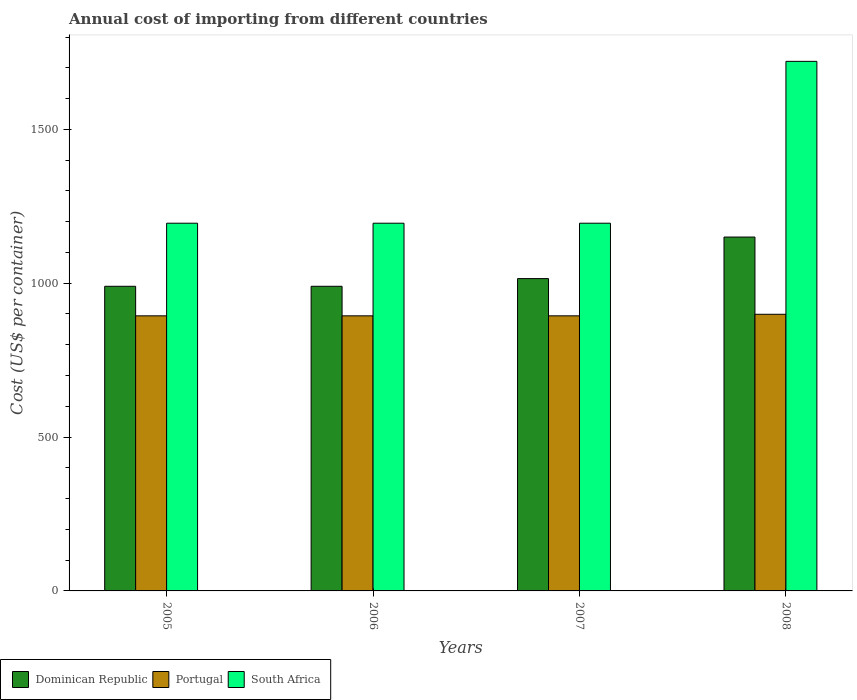How many different coloured bars are there?
Your answer should be very brief. 3. Are the number of bars per tick equal to the number of legend labels?
Offer a very short reply. Yes. What is the label of the 4th group of bars from the left?
Give a very brief answer. 2008. What is the total annual cost of importing in Portugal in 2008?
Give a very brief answer. 899. Across all years, what is the maximum total annual cost of importing in Portugal?
Offer a terse response. 899. Across all years, what is the minimum total annual cost of importing in South Africa?
Offer a very short reply. 1195. In which year was the total annual cost of importing in Portugal maximum?
Offer a terse response. 2008. In which year was the total annual cost of importing in Dominican Republic minimum?
Your answer should be compact. 2005. What is the total total annual cost of importing in Portugal in the graph?
Your answer should be compact. 3581. What is the difference between the total annual cost of importing in South Africa in 2007 and that in 2008?
Offer a very short reply. -526. What is the difference between the total annual cost of importing in Portugal in 2008 and the total annual cost of importing in South Africa in 2007?
Offer a very short reply. -296. What is the average total annual cost of importing in Portugal per year?
Offer a terse response. 895.25. In the year 2005, what is the difference between the total annual cost of importing in Portugal and total annual cost of importing in South Africa?
Give a very brief answer. -301. Is the total annual cost of importing in Portugal in 2007 less than that in 2008?
Your response must be concise. Yes. What is the difference between the highest and the second highest total annual cost of importing in Portugal?
Ensure brevity in your answer.  5. What is the difference between the highest and the lowest total annual cost of importing in Dominican Republic?
Your answer should be very brief. 160. In how many years, is the total annual cost of importing in Portugal greater than the average total annual cost of importing in Portugal taken over all years?
Provide a short and direct response. 1. What does the 1st bar from the left in 2008 represents?
Offer a very short reply. Dominican Republic. What does the 1st bar from the right in 2007 represents?
Offer a terse response. South Africa. Are all the bars in the graph horizontal?
Your response must be concise. No. How many years are there in the graph?
Offer a terse response. 4. What is the difference between two consecutive major ticks on the Y-axis?
Offer a terse response. 500. Are the values on the major ticks of Y-axis written in scientific E-notation?
Your answer should be very brief. No. Where does the legend appear in the graph?
Make the answer very short. Bottom left. How many legend labels are there?
Offer a very short reply. 3. What is the title of the graph?
Provide a short and direct response. Annual cost of importing from different countries. What is the label or title of the X-axis?
Your answer should be very brief. Years. What is the label or title of the Y-axis?
Offer a terse response. Cost (US$ per container). What is the Cost (US$ per container) in Dominican Republic in 2005?
Provide a succinct answer. 990. What is the Cost (US$ per container) in Portugal in 2005?
Make the answer very short. 894. What is the Cost (US$ per container) in South Africa in 2005?
Offer a terse response. 1195. What is the Cost (US$ per container) in Dominican Republic in 2006?
Give a very brief answer. 990. What is the Cost (US$ per container) in Portugal in 2006?
Offer a terse response. 894. What is the Cost (US$ per container) of South Africa in 2006?
Your answer should be compact. 1195. What is the Cost (US$ per container) in Dominican Republic in 2007?
Give a very brief answer. 1015. What is the Cost (US$ per container) in Portugal in 2007?
Ensure brevity in your answer.  894. What is the Cost (US$ per container) of South Africa in 2007?
Your answer should be compact. 1195. What is the Cost (US$ per container) in Dominican Republic in 2008?
Keep it short and to the point. 1150. What is the Cost (US$ per container) of Portugal in 2008?
Make the answer very short. 899. What is the Cost (US$ per container) of South Africa in 2008?
Provide a short and direct response. 1721. Across all years, what is the maximum Cost (US$ per container) of Dominican Republic?
Your answer should be compact. 1150. Across all years, what is the maximum Cost (US$ per container) in Portugal?
Your response must be concise. 899. Across all years, what is the maximum Cost (US$ per container) of South Africa?
Provide a short and direct response. 1721. Across all years, what is the minimum Cost (US$ per container) of Dominican Republic?
Your answer should be very brief. 990. Across all years, what is the minimum Cost (US$ per container) in Portugal?
Your answer should be very brief. 894. Across all years, what is the minimum Cost (US$ per container) of South Africa?
Your response must be concise. 1195. What is the total Cost (US$ per container) in Dominican Republic in the graph?
Keep it short and to the point. 4145. What is the total Cost (US$ per container) of Portugal in the graph?
Provide a short and direct response. 3581. What is the total Cost (US$ per container) in South Africa in the graph?
Ensure brevity in your answer.  5306. What is the difference between the Cost (US$ per container) of Dominican Republic in 2005 and that in 2006?
Offer a very short reply. 0. What is the difference between the Cost (US$ per container) in South Africa in 2005 and that in 2006?
Your response must be concise. 0. What is the difference between the Cost (US$ per container) of Dominican Republic in 2005 and that in 2008?
Offer a terse response. -160. What is the difference between the Cost (US$ per container) in Portugal in 2005 and that in 2008?
Keep it short and to the point. -5. What is the difference between the Cost (US$ per container) of South Africa in 2005 and that in 2008?
Offer a very short reply. -526. What is the difference between the Cost (US$ per container) in Dominican Republic in 2006 and that in 2008?
Offer a terse response. -160. What is the difference between the Cost (US$ per container) of Portugal in 2006 and that in 2008?
Offer a terse response. -5. What is the difference between the Cost (US$ per container) in South Africa in 2006 and that in 2008?
Make the answer very short. -526. What is the difference between the Cost (US$ per container) of Dominican Republic in 2007 and that in 2008?
Your response must be concise. -135. What is the difference between the Cost (US$ per container) in South Africa in 2007 and that in 2008?
Offer a terse response. -526. What is the difference between the Cost (US$ per container) in Dominican Republic in 2005 and the Cost (US$ per container) in Portugal in 2006?
Give a very brief answer. 96. What is the difference between the Cost (US$ per container) in Dominican Republic in 2005 and the Cost (US$ per container) in South Africa in 2006?
Give a very brief answer. -205. What is the difference between the Cost (US$ per container) in Portugal in 2005 and the Cost (US$ per container) in South Africa in 2006?
Offer a terse response. -301. What is the difference between the Cost (US$ per container) in Dominican Republic in 2005 and the Cost (US$ per container) in Portugal in 2007?
Your response must be concise. 96. What is the difference between the Cost (US$ per container) of Dominican Republic in 2005 and the Cost (US$ per container) of South Africa in 2007?
Offer a very short reply. -205. What is the difference between the Cost (US$ per container) of Portugal in 2005 and the Cost (US$ per container) of South Africa in 2007?
Offer a very short reply. -301. What is the difference between the Cost (US$ per container) in Dominican Republic in 2005 and the Cost (US$ per container) in Portugal in 2008?
Your answer should be very brief. 91. What is the difference between the Cost (US$ per container) in Dominican Republic in 2005 and the Cost (US$ per container) in South Africa in 2008?
Provide a short and direct response. -731. What is the difference between the Cost (US$ per container) in Portugal in 2005 and the Cost (US$ per container) in South Africa in 2008?
Offer a terse response. -827. What is the difference between the Cost (US$ per container) of Dominican Republic in 2006 and the Cost (US$ per container) of Portugal in 2007?
Provide a short and direct response. 96. What is the difference between the Cost (US$ per container) in Dominican Republic in 2006 and the Cost (US$ per container) in South Africa in 2007?
Make the answer very short. -205. What is the difference between the Cost (US$ per container) of Portugal in 2006 and the Cost (US$ per container) of South Africa in 2007?
Provide a succinct answer. -301. What is the difference between the Cost (US$ per container) of Dominican Republic in 2006 and the Cost (US$ per container) of Portugal in 2008?
Offer a very short reply. 91. What is the difference between the Cost (US$ per container) of Dominican Republic in 2006 and the Cost (US$ per container) of South Africa in 2008?
Offer a very short reply. -731. What is the difference between the Cost (US$ per container) in Portugal in 2006 and the Cost (US$ per container) in South Africa in 2008?
Give a very brief answer. -827. What is the difference between the Cost (US$ per container) of Dominican Republic in 2007 and the Cost (US$ per container) of Portugal in 2008?
Offer a very short reply. 116. What is the difference between the Cost (US$ per container) in Dominican Republic in 2007 and the Cost (US$ per container) in South Africa in 2008?
Provide a succinct answer. -706. What is the difference between the Cost (US$ per container) in Portugal in 2007 and the Cost (US$ per container) in South Africa in 2008?
Provide a succinct answer. -827. What is the average Cost (US$ per container) in Dominican Republic per year?
Provide a succinct answer. 1036.25. What is the average Cost (US$ per container) in Portugal per year?
Offer a terse response. 895.25. What is the average Cost (US$ per container) in South Africa per year?
Make the answer very short. 1326.5. In the year 2005, what is the difference between the Cost (US$ per container) in Dominican Republic and Cost (US$ per container) in Portugal?
Provide a succinct answer. 96. In the year 2005, what is the difference between the Cost (US$ per container) of Dominican Republic and Cost (US$ per container) of South Africa?
Your answer should be compact. -205. In the year 2005, what is the difference between the Cost (US$ per container) in Portugal and Cost (US$ per container) in South Africa?
Provide a short and direct response. -301. In the year 2006, what is the difference between the Cost (US$ per container) in Dominican Republic and Cost (US$ per container) in Portugal?
Provide a short and direct response. 96. In the year 2006, what is the difference between the Cost (US$ per container) in Dominican Republic and Cost (US$ per container) in South Africa?
Ensure brevity in your answer.  -205. In the year 2006, what is the difference between the Cost (US$ per container) of Portugal and Cost (US$ per container) of South Africa?
Provide a succinct answer. -301. In the year 2007, what is the difference between the Cost (US$ per container) of Dominican Republic and Cost (US$ per container) of Portugal?
Give a very brief answer. 121. In the year 2007, what is the difference between the Cost (US$ per container) of Dominican Republic and Cost (US$ per container) of South Africa?
Ensure brevity in your answer.  -180. In the year 2007, what is the difference between the Cost (US$ per container) of Portugal and Cost (US$ per container) of South Africa?
Ensure brevity in your answer.  -301. In the year 2008, what is the difference between the Cost (US$ per container) of Dominican Republic and Cost (US$ per container) of Portugal?
Offer a terse response. 251. In the year 2008, what is the difference between the Cost (US$ per container) of Dominican Republic and Cost (US$ per container) of South Africa?
Your answer should be compact. -571. In the year 2008, what is the difference between the Cost (US$ per container) in Portugal and Cost (US$ per container) in South Africa?
Give a very brief answer. -822. What is the ratio of the Cost (US$ per container) in Dominican Republic in 2005 to that in 2006?
Ensure brevity in your answer.  1. What is the ratio of the Cost (US$ per container) in South Africa in 2005 to that in 2006?
Your answer should be very brief. 1. What is the ratio of the Cost (US$ per container) of Dominican Republic in 2005 to that in 2007?
Offer a terse response. 0.98. What is the ratio of the Cost (US$ per container) in Portugal in 2005 to that in 2007?
Keep it short and to the point. 1. What is the ratio of the Cost (US$ per container) in Dominican Republic in 2005 to that in 2008?
Offer a terse response. 0.86. What is the ratio of the Cost (US$ per container) of South Africa in 2005 to that in 2008?
Your answer should be compact. 0.69. What is the ratio of the Cost (US$ per container) of Dominican Republic in 2006 to that in 2007?
Provide a succinct answer. 0.98. What is the ratio of the Cost (US$ per container) in Dominican Republic in 2006 to that in 2008?
Offer a terse response. 0.86. What is the ratio of the Cost (US$ per container) in South Africa in 2006 to that in 2008?
Offer a very short reply. 0.69. What is the ratio of the Cost (US$ per container) in Dominican Republic in 2007 to that in 2008?
Your answer should be very brief. 0.88. What is the ratio of the Cost (US$ per container) in South Africa in 2007 to that in 2008?
Keep it short and to the point. 0.69. What is the difference between the highest and the second highest Cost (US$ per container) of Dominican Republic?
Provide a succinct answer. 135. What is the difference between the highest and the second highest Cost (US$ per container) of Portugal?
Provide a succinct answer. 5. What is the difference between the highest and the second highest Cost (US$ per container) in South Africa?
Make the answer very short. 526. What is the difference between the highest and the lowest Cost (US$ per container) in Dominican Republic?
Keep it short and to the point. 160. What is the difference between the highest and the lowest Cost (US$ per container) in South Africa?
Offer a terse response. 526. 